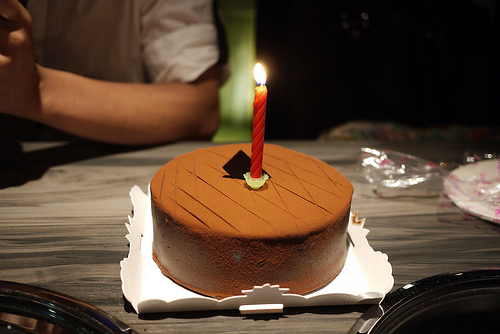<image>
Is there a fire above the candle? Yes. The fire is positioned above the candle in the vertical space, higher up in the scene. Is the candle behind the cake? No. The candle is not behind the cake. From this viewpoint, the candle appears to be positioned elsewhere in the scene. Where is the flame in relation to the table? Is it to the left of the table? No. The flame is not to the left of the table. From this viewpoint, they have a different horizontal relationship. 